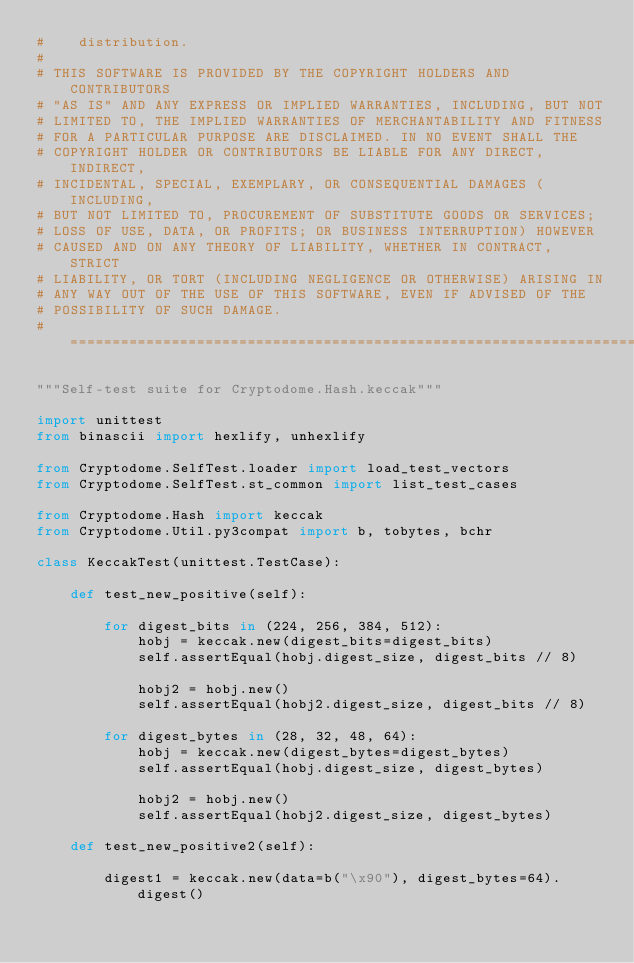<code> <loc_0><loc_0><loc_500><loc_500><_Python_>#    distribution.
#
# THIS SOFTWARE IS PROVIDED BY THE COPYRIGHT HOLDERS AND CONTRIBUTORS
# "AS IS" AND ANY EXPRESS OR IMPLIED WARRANTIES, INCLUDING, BUT NOT
# LIMITED TO, THE IMPLIED WARRANTIES OF MERCHANTABILITY AND FITNESS
# FOR A PARTICULAR PURPOSE ARE DISCLAIMED. IN NO EVENT SHALL THE
# COPYRIGHT HOLDER OR CONTRIBUTORS BE LIABLE FOR ANY DIRECT, INDIRECT,
# INCIDENTAL, SPECIAL, EXEMPLARY, OR CONSEQUENTIAL DAMAGES (INCLUDING,
# BUT NOT LIMITED TO, PROCUREMENT OF SUBSTITUTE GOODS OR SERVICES;
# LOSS OF USE, DATA, OR PROFITS; OR BUSINESS INTERRUPTION) HOWEVER
# CAUSED AND ON ANY THEORY OF LIABILITY, WHETHER IN CONTRACT, STRICT
# LIABILITY, OR TORT (INCLUDING NEGLIGENCE OR OTHERWISE) ARISING IN
# ANY WAY OUT OF THE USE OF THIS SOFTWARE, EVEN IF ADVISED OF THE
# POSSIBILITY OF SUCH DAMAGE.
# ===================================================================

"""Self-test suite for Cryptodome.Hash.keccak"""

import unittest
from binascii import hexlify, unhexlify

from Cryptodome.SelfTest.loader import load_test_vectors
from Cryptodome.SelfTest.st_common import list_test_cases

from Cryptodome.Hash import keccak
from Cryptodome.Util.py3compat import b, tobytes, bchr

class KeccakTest(unittest.TestCase):

    def test_new_positive(self):

        for digest_bits in (224, 256, 384, 512):
            hobj = keccak.new(digest_bits=digest_bits)
            self.assertEqual(hobj.digest_size, digest_bits // 8)

            hobj2 = hobj.new()
            self.assertEqual(hobj2.digest_size, digest_bits // 8)

        for digest_bytes in (28, 32, 48, 64):
            hobj = keccak.new(digest_bytes=digest_bytes)
            self.assertEqual(hobj.digest_size, digest_bytes)

            hobj2 = hobj.new()
            self.assertEqual(hobj2.digest_size, digest_bytes)

    def test_new_positive2(self):

        digest1 = keccak.new(data=b("\x90"), digest_bytes=64).digest()</code> 